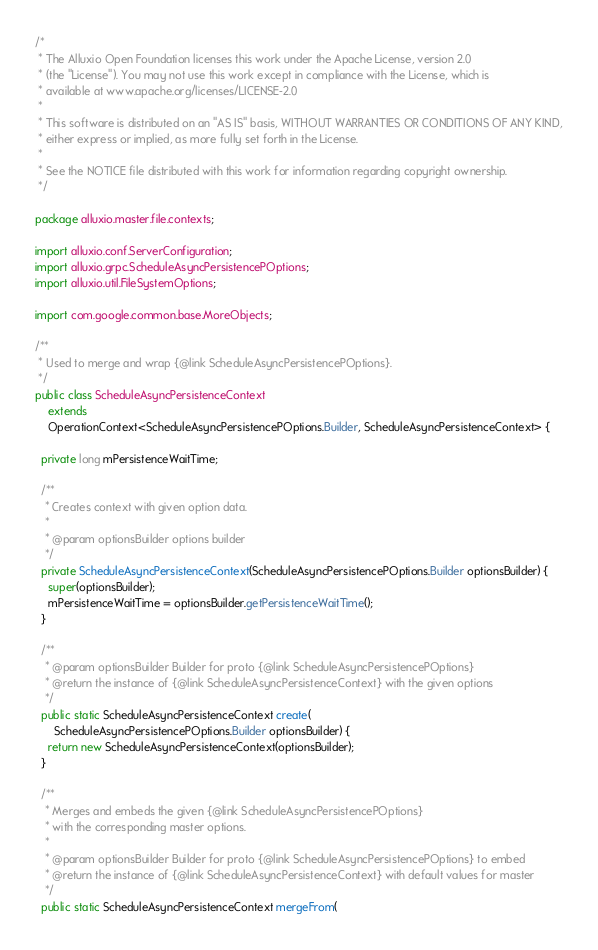Convert code to text. <code><loc_0><loc_0><loc_500><loc_500><_Java_>/*
 * The Alluxio Open Foundation licenses this work under the Apache License, version 2.0
 * (the "License"). You may not use this work except in compliance with the License, which is
 * available at www.apache.org/licenses/LICENSE-2.0
 *
 * This software is distributed on an "AS IS" basis, WITHOUT WARRANTIES OR CONDITIONS OF ANY KIND,
 * either express or implied, as more fully set forth in the License.
 *
 * See the NOTICE file distributed with this work for information regarding copyright ownership.
 */

package alluxio.master.file.contexts;

import alluxio.conf.ServerConfiguration;
import alluxio.grpc.ScheduleAsyncPersistencePOptions;
import alluxio.util.FileSystemOptions;

import com.google.common.base.MoreObjects;

/**
 * Used to merge and wrap {@link ScheduleAsyncPersistencePOptions}.
 */
public class ScheduleAsyncPersistenceContext
    extends
    OperationContext<ScheduleAsyncPersistencePOptions.Builder, ScheduleAsyncPersistenceContext> {

  private long mPersistenceWaitTime;

  /**
   * Creates context with given option data.
   *
   * @param optionsBuilder options builder
   */
  private ScheduleAsyncPersistenceContext(ScheduleAsyncPersistencePOptions.Builder optionsBuilder) {
    super(optionsBuilder);
    mPersistenceWaitTime = optionsBuilder.getPersistenceWaitTime();
  }

  /**
   * @param optionsBuilder Builder for proto {@link ScheduleAsyncPersistencePOptions}
   * @return the instance of {@link ScheduleAsyncPersistenceContext} with the given options
   */
  public static ScheduleAsyncPersistenceContext create(
      ScheduleAsyncPersistencePOptions.Builder optionsBuilder) {
    return new ScheduleAsyncPersistenceContext(optionsBuilder);
  }

  /**
   * Merges and embeds the given {@link ScheduleAsyncPersistencePOptions}
   * with the corresponding master options.
   *
   * @param optionsBuilder Builder for proto {@link ScheduleAsyncPersistencePOptions} to embed
   * @return the instance of {@link ScheduleAsyncPersistenceContext} with default values for master
   */
  public static ScheduleAsyncPersistenceContext mergeFrom(</code> 